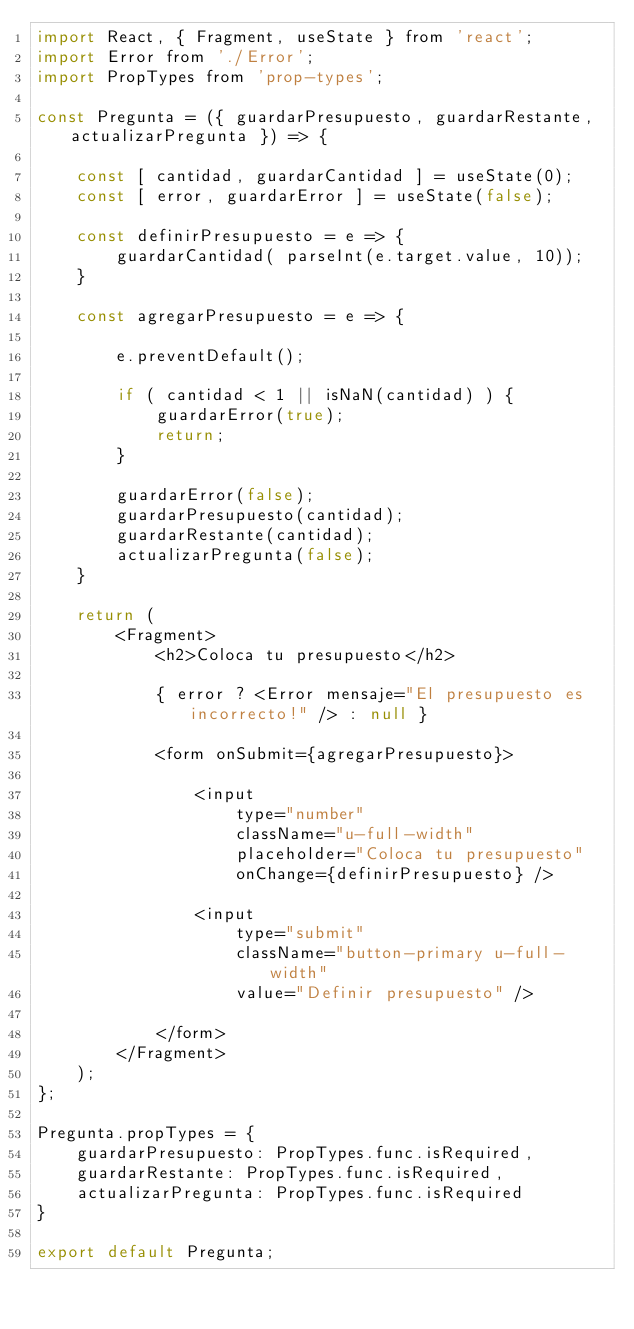<code> <loc_0><loc_0><loc_500><loc_500><_JavaScript_>import React, { Fragment, useState } from 'react';
import Error from './Error';
import PropTypes from 'prop-types';

const Pregunta = ({ guardarPresupuesto, guardarRestante, actualizarPregunta }) => {

    const [ cantidad, guardarCantidad ] = useState(0); 
    const [ error, guardarError ] = useState(false);

    const definirPresupuesto = e => {
        guardarCantidad( parseInt(e.target.value, 10));
    }

    const agregarPresupuesto = e => {
        
        e.preventDefault();

        if ( cantidad < 1 || isNaN(cantidad) ) {
            guardarError(true);
            return;
        }

        guardarError(false);
        guardarPresupuesto(cantidad);
        guardarRestante(cantidad);
        actualizarPregunta(false);
    }

    return (
        <Fragment>
            <h2>Coloca tu presupuesto</h2>

            { error ? <Error mensaje="El presupuesto es incorrecto!" /> : null }

            <form onSubmit={agregarPresupuesto}>

                <input
                    type="number"
                    className="u-full-width"
                    placeholder="Coloca tu presupuesto"
                    onChange={definirPresupuesto} />
                
                <input
                    type="submit"
                    className="button-primary u-full-width"
                    value="Definir presupuesto" />
            
            </form>
        </Fragment>
    );
};

Pregunta.propTypes = {
    guardarPresupuesto: PropTypes.func.isRequired,
    guardarRestante: PropTypes.func.isRequired,
    actualizarPregunta: PropTypes.func.isRequired
}

export default Pregunta;</code> 